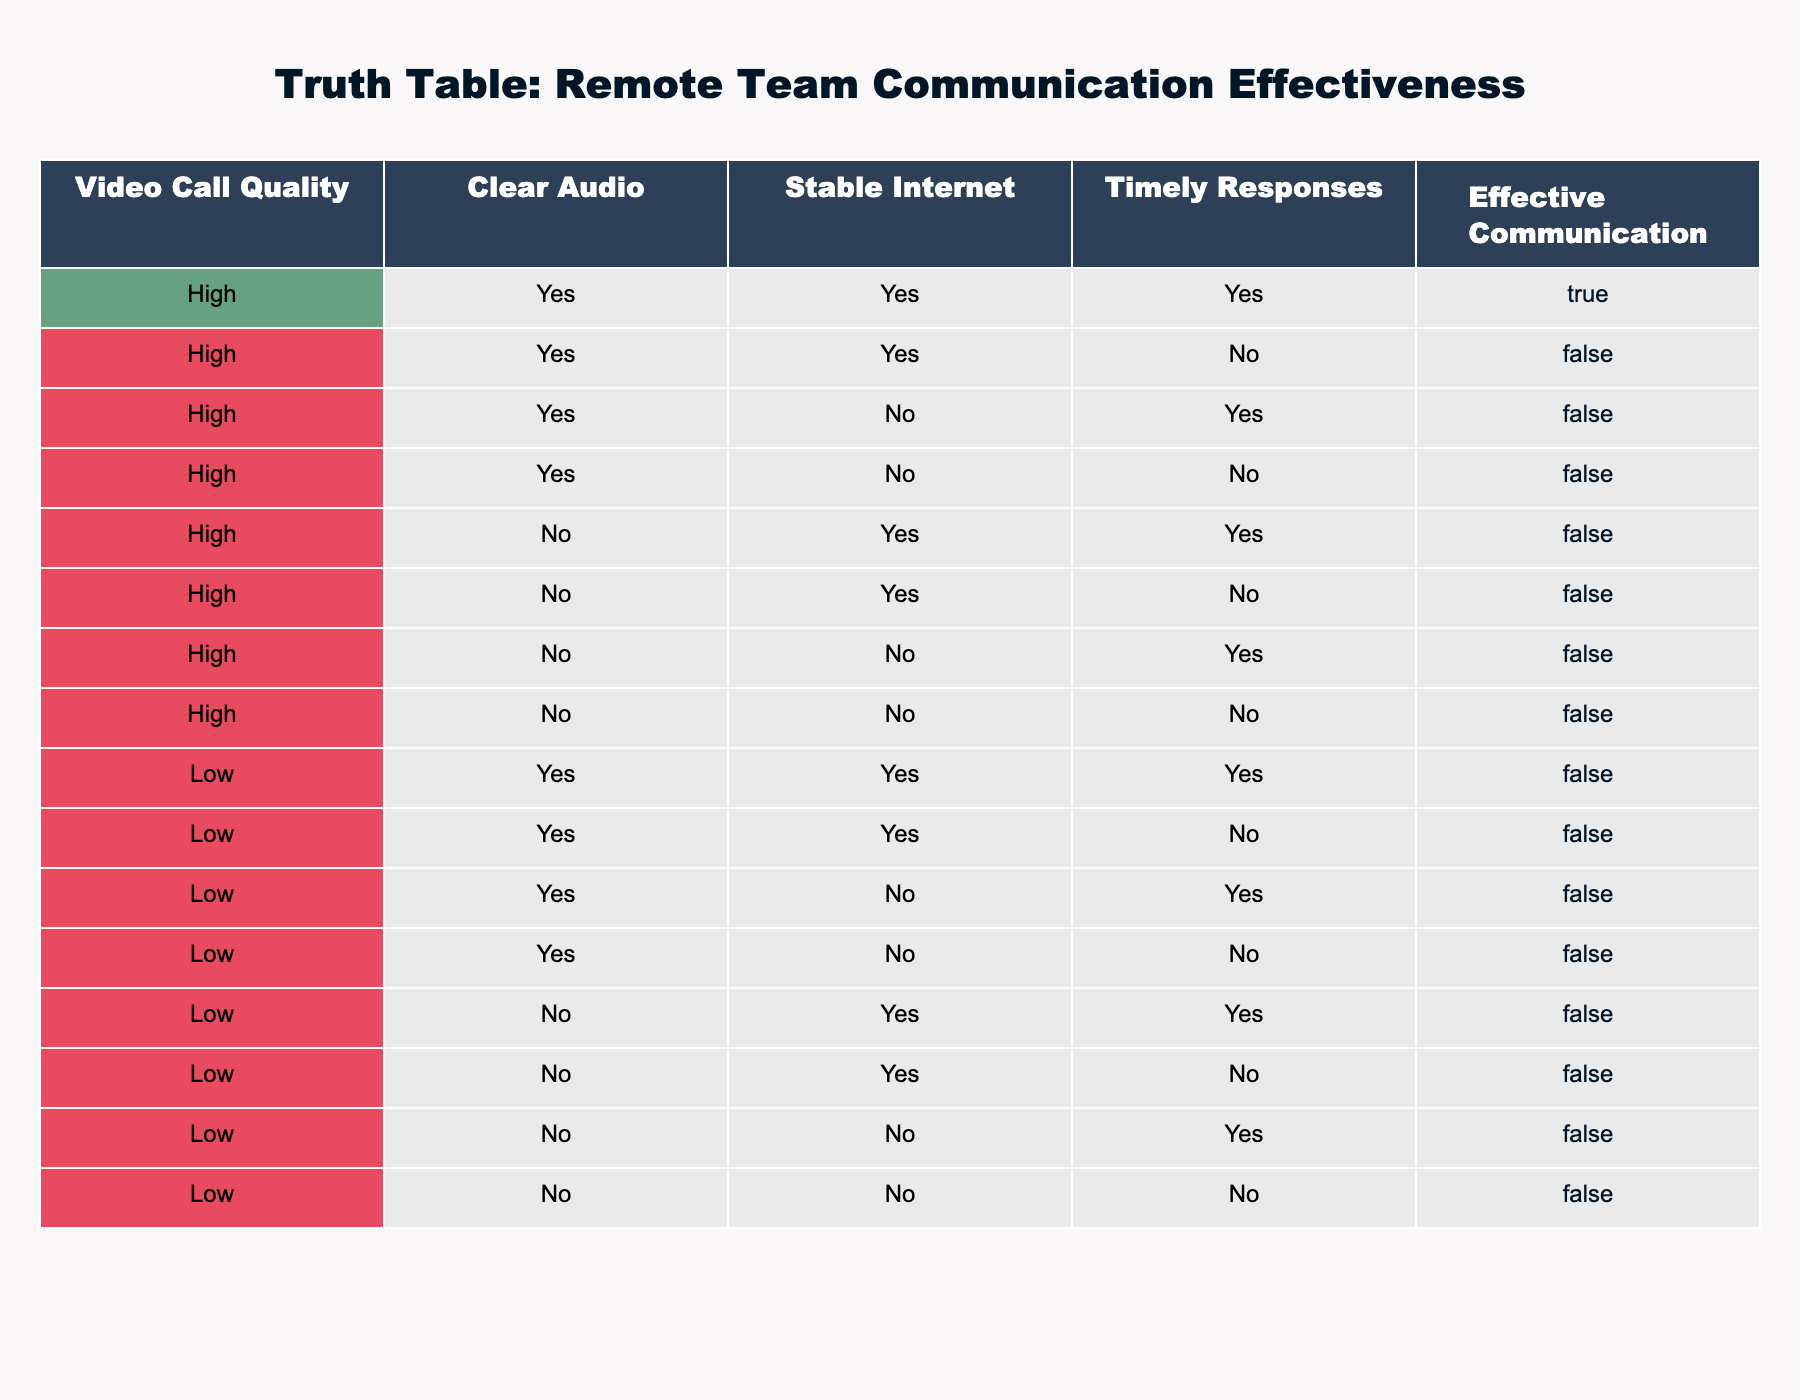What percentage of entries report effective communication with high video call quality? There are 8 entries with high video call quality. Out of these, only 1 entry shows effective communication. Therefore, the percentage is (1 effective communication / 8 total) * 100 = 12.5%.
Answer: 12.5% How many total entries are there in the table? There are 16 total entries in the table. Each row represents a unique combination of conditions related to remote team communication.
Answer: 16 Is effective communication ever reported with low video call quality? In examining the entries with low video call quality, all the instances show ineffective communication (False) as per the table. Therefore, the answer is no, it is never reported.
Answer: No What is the total number of entries where clear audio and timely responses both occurred? There are 4 entries (3 for high video call quality and 1 for low video call quality) where both clear audio and timely responses are reported. The rows with these conditions can be directly referenced in the table.
Answer: 4 If we filter for stable internet, what is the average effective communication value of those entries? For the entries that have stable internet (True), we find a total of 6 entries. Out of these, only 1 shows effective communication as True, leading to an average value of (1 effective communication / 6 total entries) = approximately 0.167.
Answer: 0.1667 How many rows show ineffective communication (False) regardless of other conditions? By scanning all entries, 15 of the total 16 rows report ineffective communication (False). Only 1 entry shows effective communication (True).
Answer: 15 If audio is not clear, what is the likelihood of effective communication? Looking at rows where audio is not clear (No), there are 8 entries, out of which only 1 shows effective communication (True). This leads to a probability of effective communication of (1 effective communication / 8 total rows with unclear audio) = 0.125.
Answer: 12.5% What is the maximum number of conditions satisfied by any single entry? By examining the entries, the one with high video call quality, clear audio, stable internet, and timely responses satisfies all 4 conditions, thus this is the maximum.
Answer: 4 